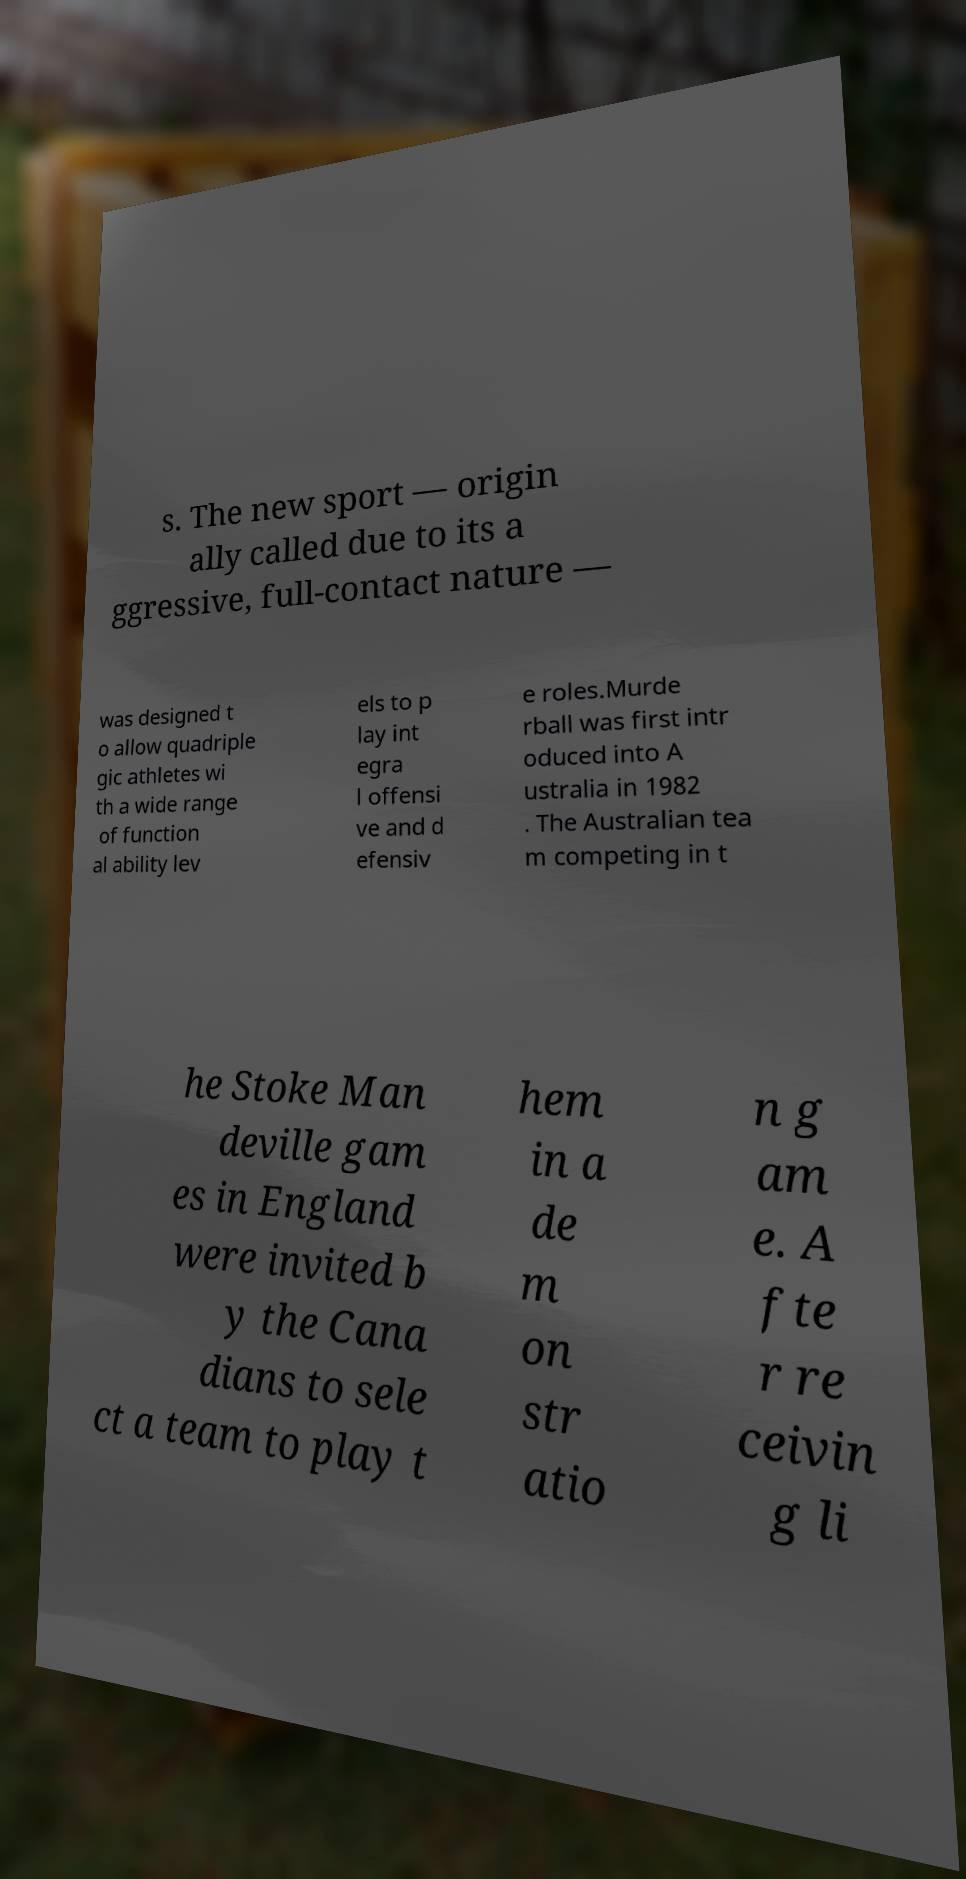I need the written content from this picture converted into text. Can you do that? s. The new sport — origin ally called due to its a ggressive, full-contact nature — was designed t o allow quadriple gic athletes wi th a wide range of function al ability lev els to p lay int egra l offensi ve and d efensiv e roles.Murde rball was first intr oduced into A ustralia in 1982 . The Australian tea m competing in t he Stoke Man deville gam es in England were invited b y the Cana dians to sele ct a team to play t hem in a de m on str atio n g am e. A fte r re ceivin g li 